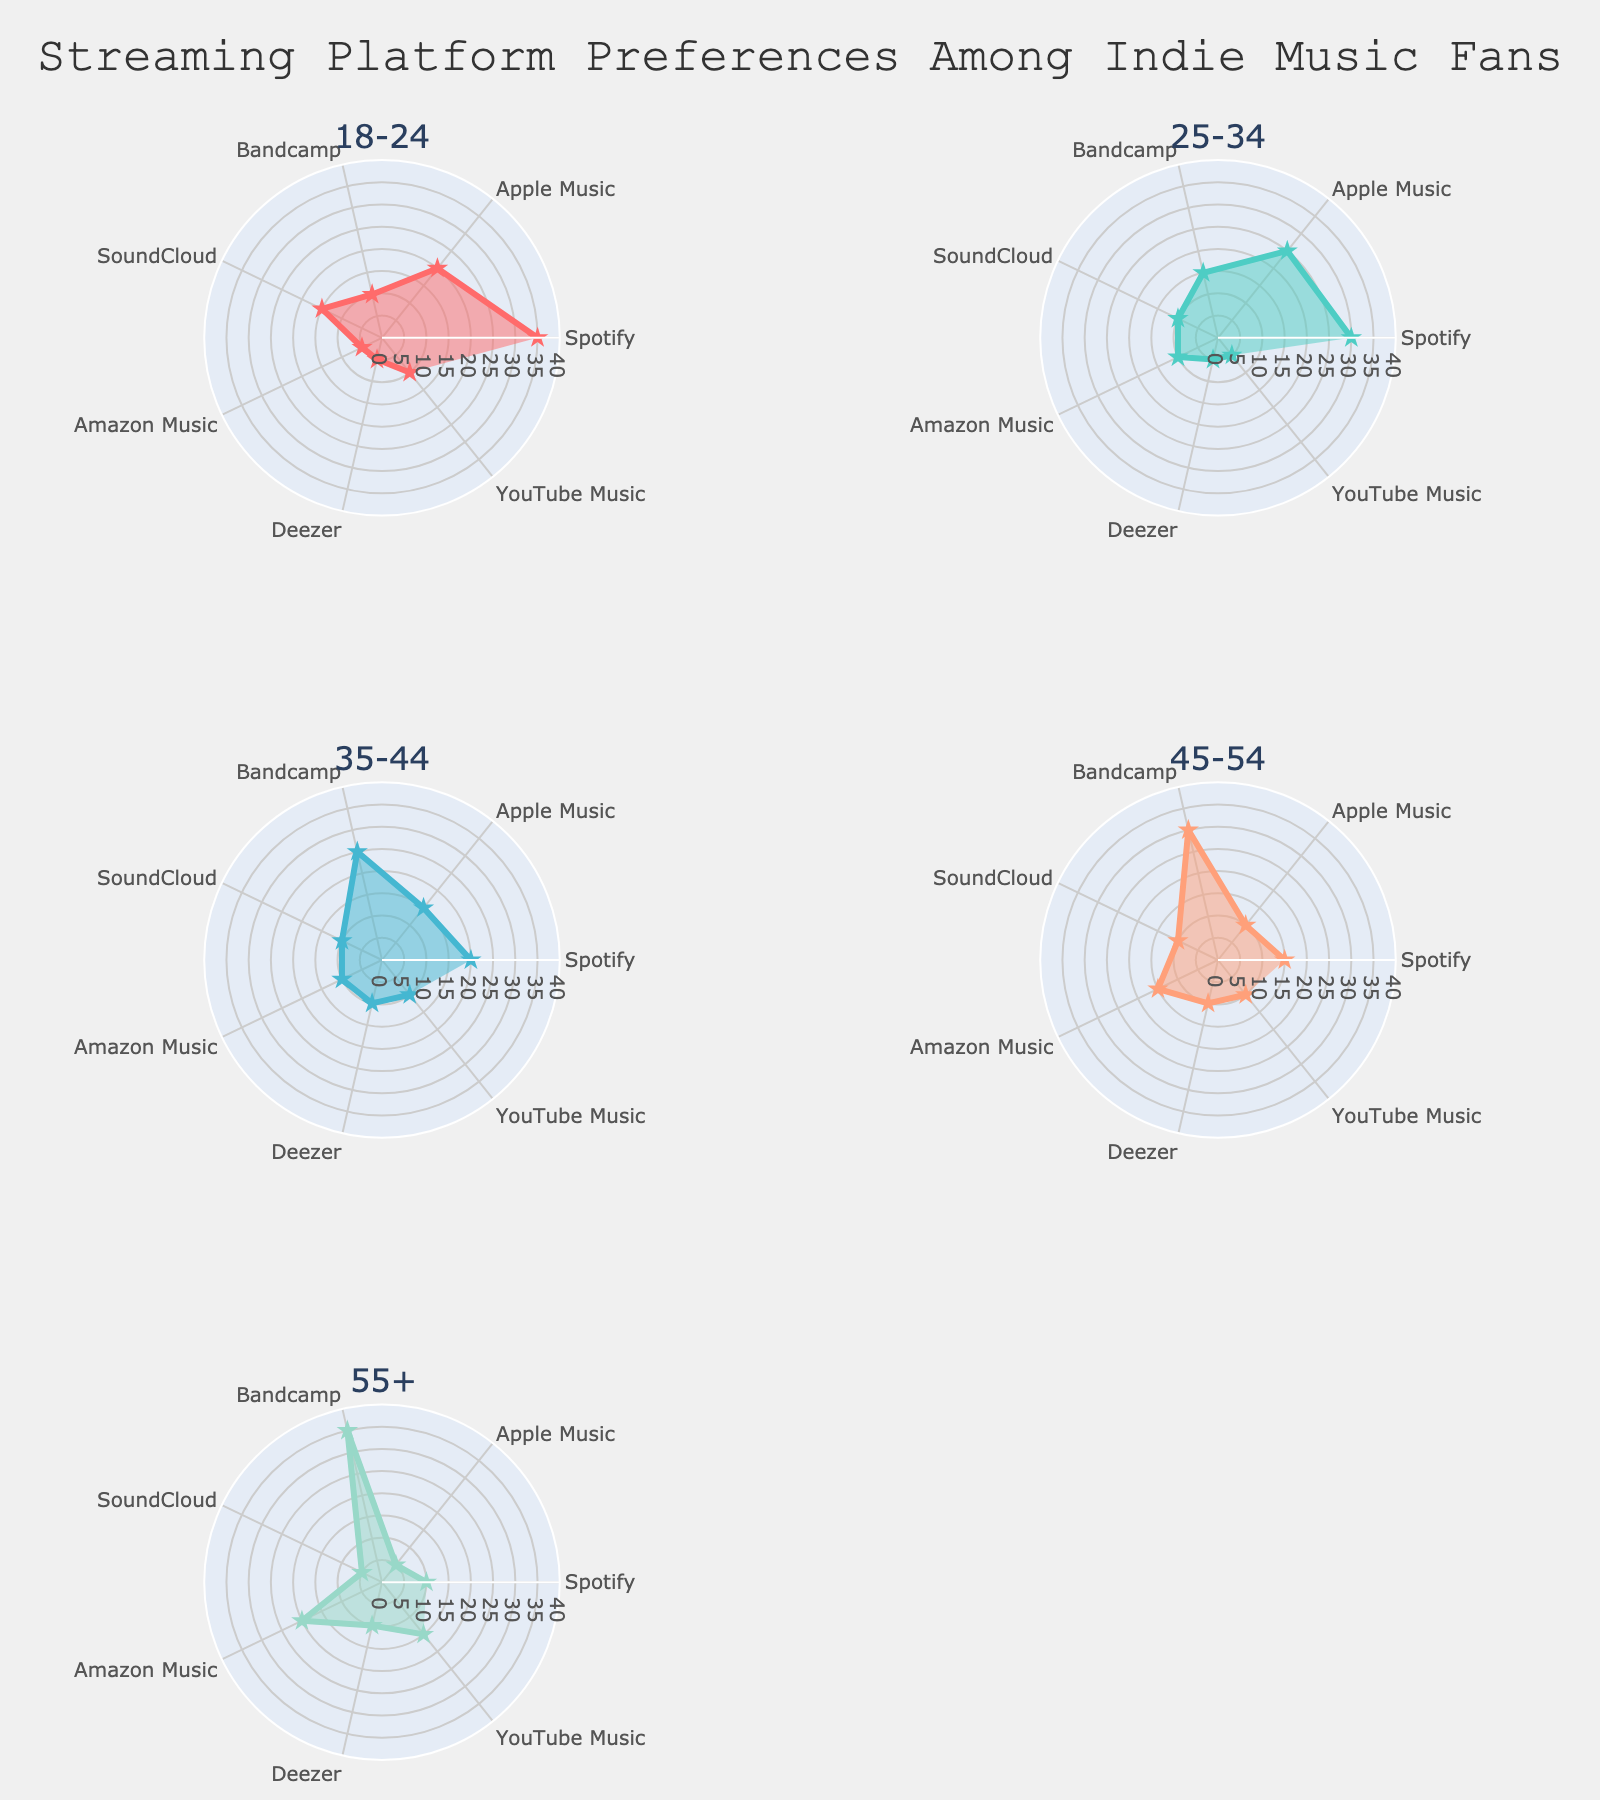What is the most popular streaming platform for the 18-24 age group? Look at the data points in the subplot for the 18-24 age group. The platform with the highest value is Spotify.
Answer: Spotify Which age group has the highest preference for Bandcamp? Compare the values for Bandcamp across all age groups. The highest value is found in the 55+ age group.
Answer: 55+ How does the preference for Apple Music change from the 18-24 age group to the 25-34 age group? Check the values for Apple Music in both subplots. The value increases from 20 to 25.
Answer: It increases What is the average preference for YouTube Music across all age groups? Sum the values of YouTube Music for all age groups (10 + 5 + 10 + 10 + 15) = 50 and divide by the number of age groups (5).
Answer: 10 Which streaming platform has the least preference in the 45-54 age group? Look at the data points in the subplot for the 45-54 age group. The platform with the lowest value is Apple Music.
Answer: Apple Music What is the range of preferences for Amazon Music across all age groups? Identify the minimum and maximum values of Amazon Music (5 and 20) and find the difference.
Answer: 15 Between Spotify and Deezer, which platform is more preferred by the 35-44 age group? Compare the values for Spotify (20) and Deezer (10) in the 35-44 age group. Spotify has a higher value.
Answer: Spotify How many age groups have a preference of 10 for SoundCloud? Identify age groups with a value of 10 for SoundCloud (there are 4 sets). The age groups are 25-34, 35-44, 45-54, and 55+.
Answer: 4 age groups Is there any age group where all platforms have a preference value of at least 5? Examine each subplot to see if minimum values are 5 or greater. All observed preferences are at least 5.
Answer: Yes For the 25-34 age group, what is the sum of preferences for platforms other than Apple Music? Sum the values of all platforms except Apple Music in the 25-34 age group: Spotify (30) + Bandcamp (15) + SoundCloud (10) + Amazon Music (10) + Deezer (5) + YouTube Music (5) = 75.
Answer: 75 